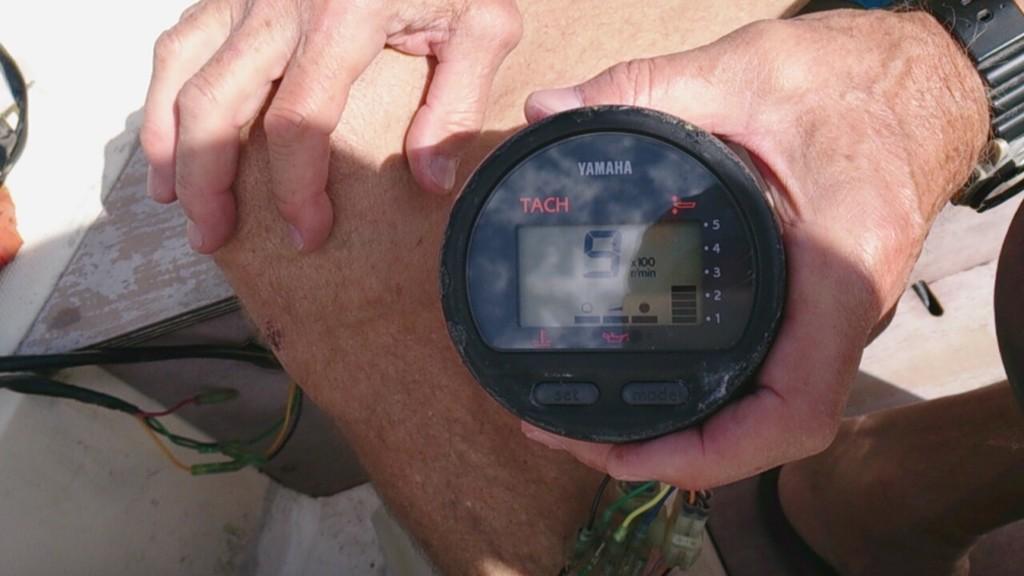Who makes this device?
Your response must be concise. Yamaha. 